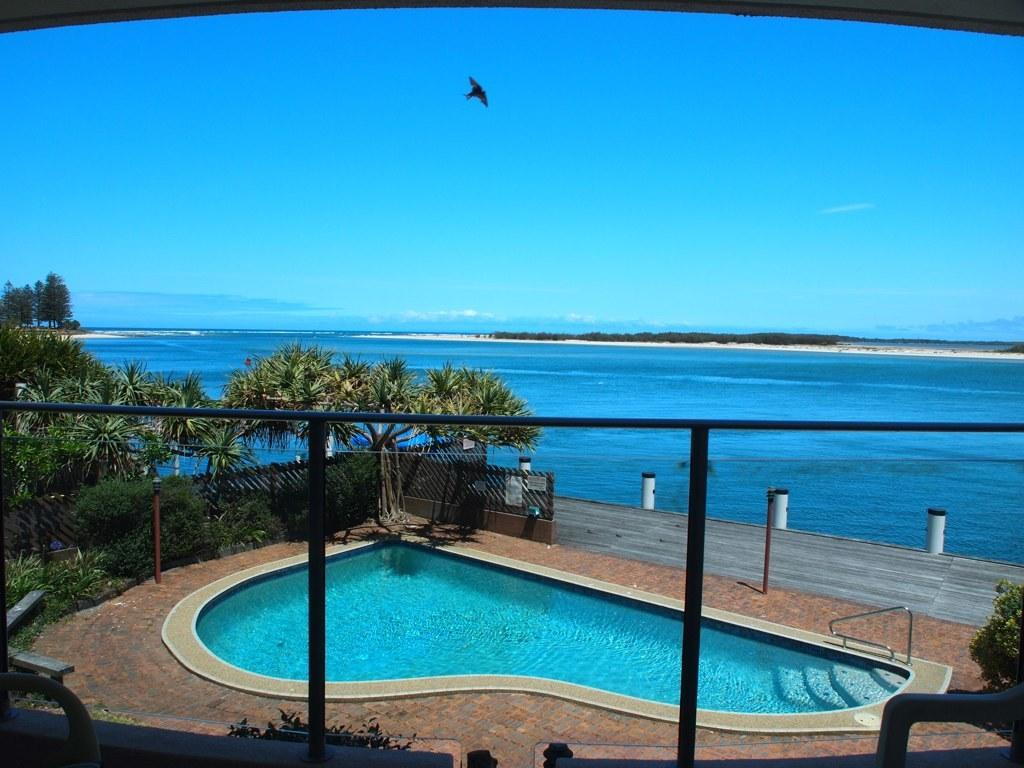What is the main feature of the image? There is a swimming pool in the image. What is located beside the swimming pool? There is a fence beside the swimming pool. What type of vegetation can be seen in the image? There are trees in the image. What is the primary element visible in the image? There is water visible in the image. What is happening in the sky in the image? There is a bird flying in the sky in the image. What type of knowledge can be gained from the map in the image? There is no map present in the image, so no knowledge can be gained from a map. 